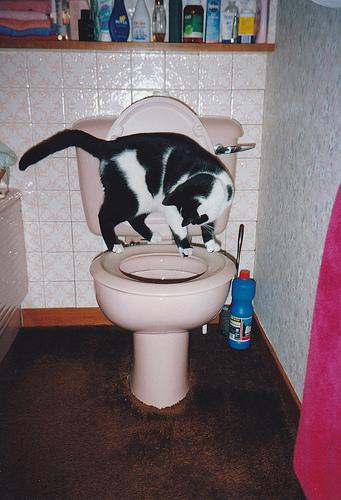Question: who is on the toilet?
Choices:
A. The boy.
B. The woman.
C. The man.
D. The cat.
Answer with the letter. Answer: D Question: what color is the cat?
Choices:
A. Grey and black.
B. Black and white.
C. White.
D. Black.
Answer with the letter. Answer: B Question: what is next to the toilet?
Choices:
A. The wash basin.
B. The shower.
C. Cleaning products.
D. The waste basket.
Answer with the letter. Answer: C Question: why is the cat there?
Choices:
A. He is curious.
B. He was told to.
C. It is is his favorite place.
D. He wants water.
Answer with the letter. Answer: D 